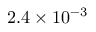Convert formula to latex. <formula><loc_0><loc_0><loc_500><loc_500>2 . 4 \times 1 0 ^ { - 3 }</formula> 